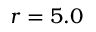Convert formula to latex. <formula><loc_0><loc_0><loc_500><loc_500>r = 5 . 0 \AA</formula> 